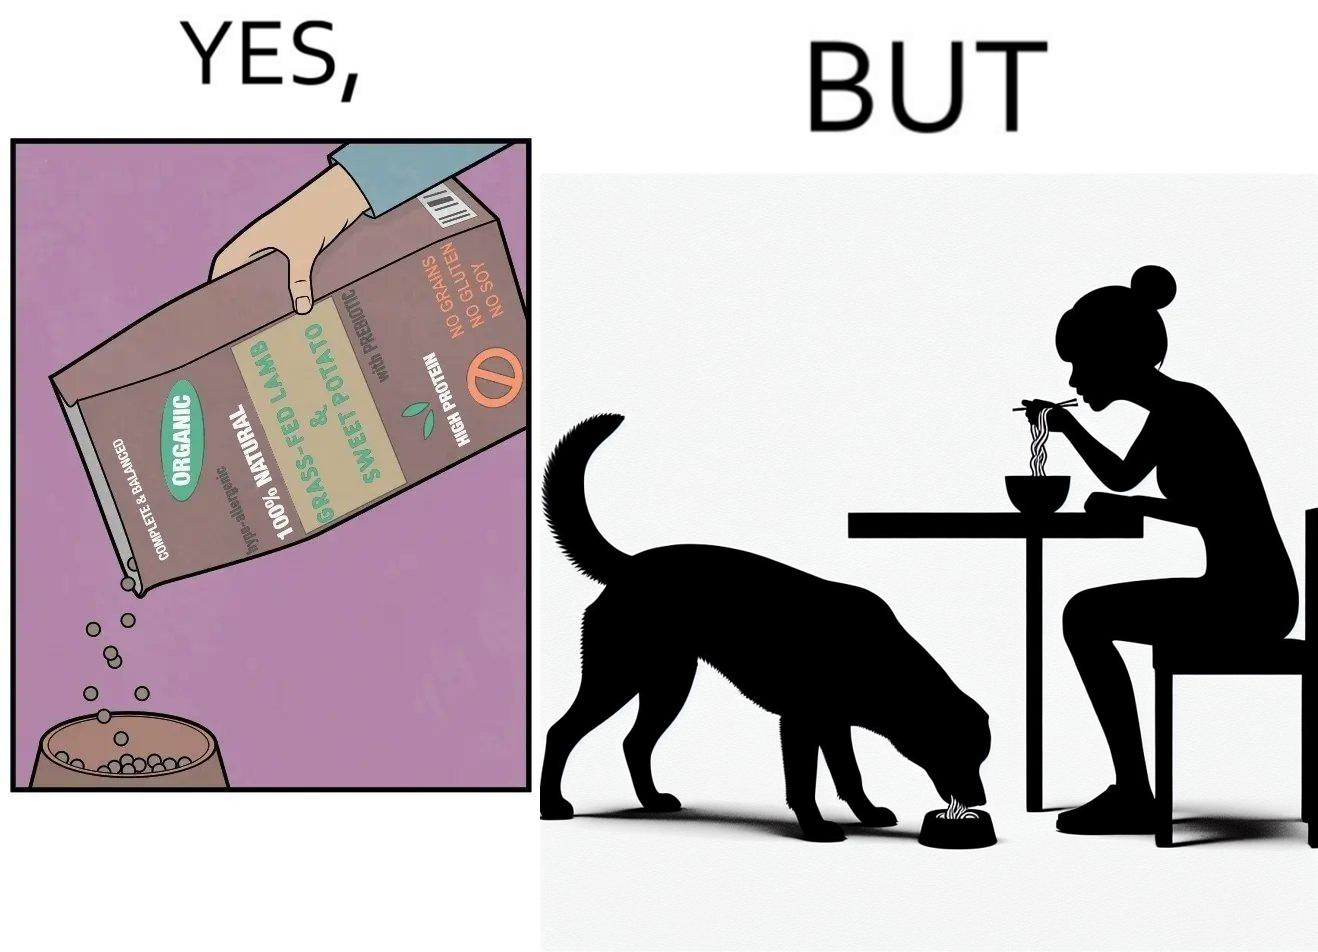Compare the left and right sides of this image. In the left part of the image: The image shows food grains being poured into a bowl from the packet. The packet says "Complete & Balanced", "Organic", "100% Natural", "Grass Fed Lamb & Sweet Potato" , "With Prebiotic", "High Protein", "No grains", "No Gluten" and "No Soy". In the right part of the image: The image shows a dog eating food from its bowl on the floor and a woman eating noodles from a cup on the table. 